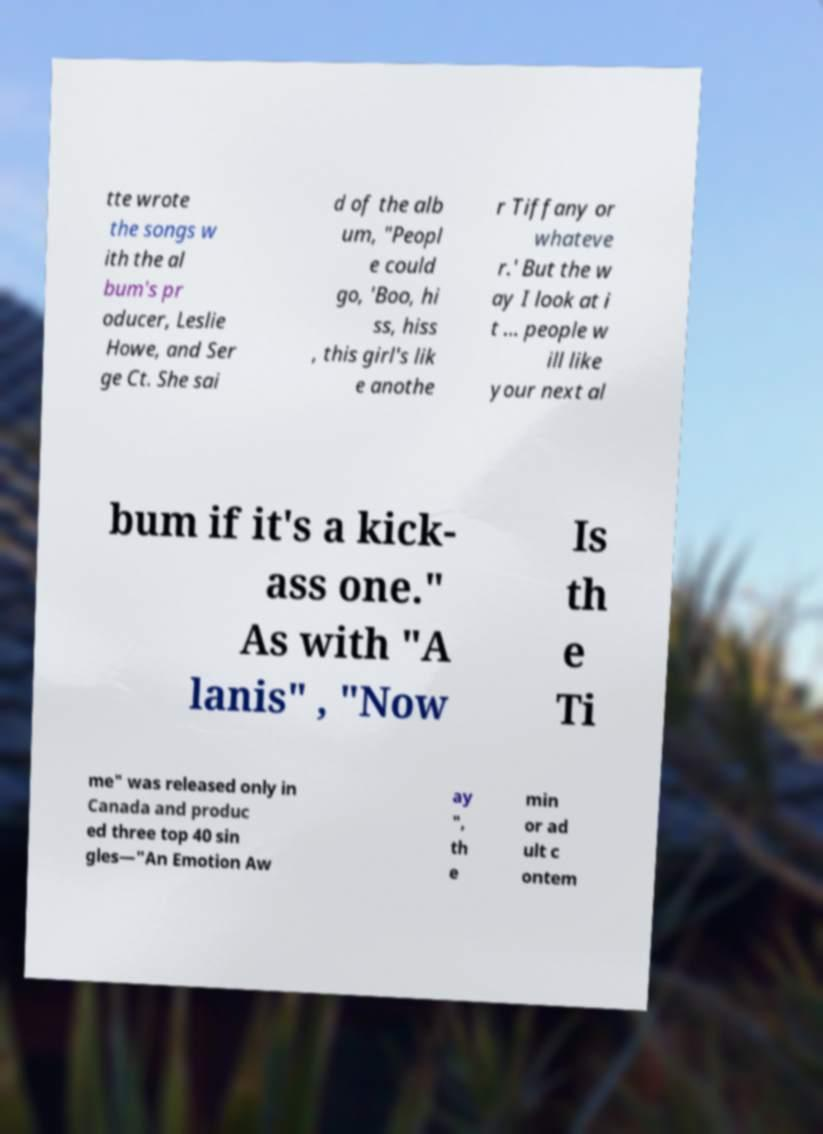Could you assist in decoding the text presented in this image and type it out clearly? tte wrote the songs w ith the al bum's pr oducer, Leslie Howe, and Ser ge Ct. She sai d of the alb um, "Peopl e could go, 'Boo, hi ss, hiss , this girl's lik e anothe r Tiffany or whateve r.' But the w ay I look at i t ... people w ill like your next al bum if it's a kick- ass one." As with "A lanis" , "Now Is th e Ti me" was released only in Canada and produc ed three top 40 sin gles—"An Emotion Aw ay ", th e min or ad ult c ontem 